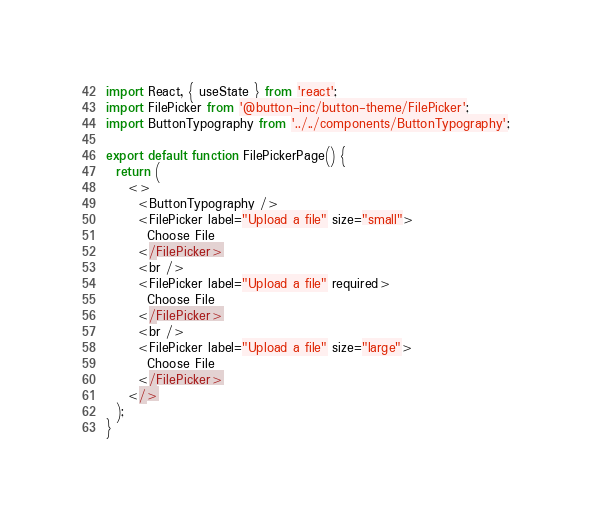Convert code to text. <code><loc_0><loc_0><loc_500><loc_500><_TypeScript_>import React, { useState } from 'react';
import FilePicker from '@button-inc/button-theme/FilePicker';
import ButtonTypography from '../../components/ButtonTypography';

export default function FilePickerPage() {
  return (
    <>
      <ButtonTypography />
      <FilePicker label="Upload a file" size="small">
        Choose File
      </FilePicker>
      <br />
      <FilePicker label="Upload a file" required>
        Choose File
      </FilePicker>
      <br />
      <FilePicker label="Upload a file" size="large">
        Choose File
      </FilePicker>
    </>
  );
}
</code> 